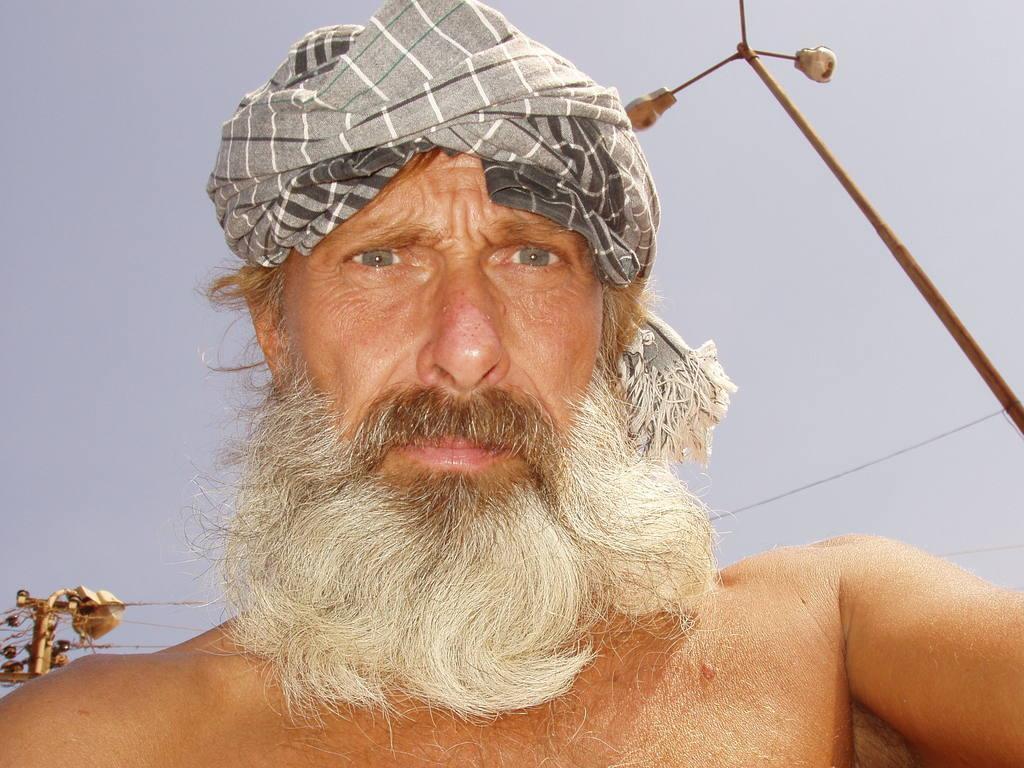How would you summarize this image in a sentence or two? In this image I can see a person. At the top I can see an electric pole and the sky. 